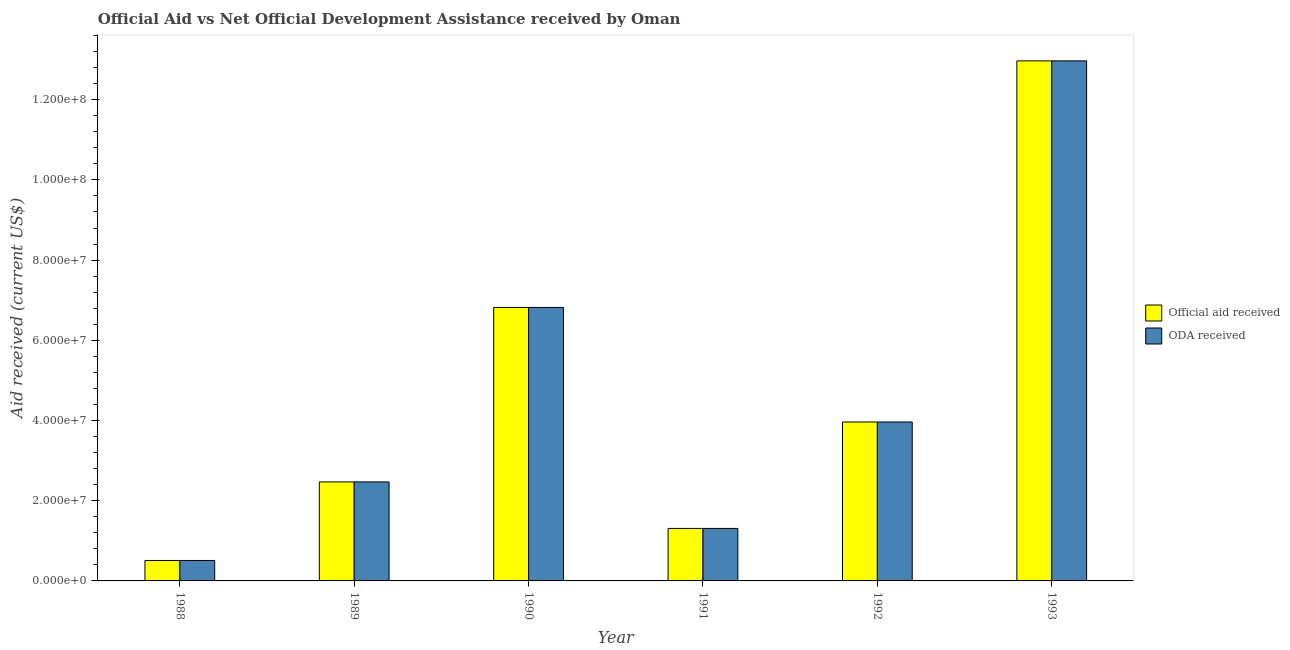How many groups of bars are there?
Your answer should be very brief. 6. Are the number of bars per tick equal to the number of legend labels?
Give a very brief answer. Yes. How many bars are there on the 3rd tick from the right?
Keep it short and to the point. 2. What is the label of the 6th group of bars from the left?
Give a very brief answer. 1993. What is the oda received in 1992?
Offer a terse response. 3.96e+07. Across all years, what is the maximum official aid received?
Offer a very short reply. 1.30e+08. Across all years, what is the minimum official aid received?
Make the answer very short. 5.10e+06. In which year was the official aid received minimum?
Provide a succinct answer. 1988. What is the total oda received in the graph?
Keep it short and to the point. 2.80e+08. What is the difference between the oda received in 1988 and that in 1989?
Your response must be concise. -1.96e+07. What is the difference between the official aid received in 1991 and the oda received in 1989?
Make the answer very short. -1.16e+07. What is the average oda received per year?
Keep it short and to the point. 4.67e+07. In the year 1990, what is the difference between the oda received and official aid received?
Provide a succinct answer. 0. What is the ratio of the oda received in 1988 to that in 1990?
Ensure brevity in your answer.  0.07. Is the oda received in 1989 less than that in 1993?
Provide a succinct answer. Yes. Is the difference between the official aid received in 1991 and 1992 greater than the difference between the oda received in 1991 and 1992?
Provide a short and direct response. No. What is the difference between the highest and the second highest oda received?
Your answer should be very brief. 6.15e+07. What is the difference between the highest and the lowest official aid received?
Offer a terse response. 1.25e+08. What does the 2nd bar from the left in 1988 represents?
Your answer should be very brief. ODA received. What does the 2nd bar from the right in 1993 represents?
Offer a very short reply. Official aid received. What is the difference between two consecutive major ticks on the Y-axis?
Your answer should be very brief. 2.00e+07. Are the values on the major ticks of Y-axis written in scientific E-notation?
Your answer should be very brief. Yes. Does the graph contain any zero values?
Your response must be concise. No. What is the title of the graph?
Offer a very short reply. Official Aid vs Net Official Development Assistance received by Oman . What is the label or title of the X-axis?
Make the answer very short. Year. What is the label or title of the Y-axis?
Ensure brevity in your answer.  Aid received (current US$). What is the Aid received (current US$) of Official aid received in 1988?
Offer a very short reply. 5.10e+06. What is the Aid received (current US$) of ODA received in 1988?
Keep it short and to the point. 5.10e+06. What is the Aid received (current US$) in Official aid received in 1989?
Offer a terse response. 2.47e+07. What is the Aid received (current US$) of ODA received in 1989?
Your answer should be compact. 2.47e+07. What is the Aid received (current US$) of Official aid received in 1990?
Make the answer very short. 6.82e+07. What is the Aid received (current US$) of ODA received in 1990?
Keep it short and to the point. 6.82e+07. What is the Aid received (current US$) of Official aid received in 1991?
Provide a succinct answer. 1.31e+07. What is the Aid received (current US$) of ODA received in 1991?
Provide a succinct answer. 1.31e+07. What is the Aid received (current US$) of Official aid received in 1992?
Your answer should be compact. 3.96e+07. What is the Aid received (current US$) of ODA received in 1992?
Your answer should be compact. 3.96e+07. What is the Aid received (current US$) in Official aid received in 1993?
Make the answer very short. 1.30e+08. What is the Aid received (current US$) of ODA received in 1993?
Your answer should be very brief. 1.30e+08. Across all years, what is the maximum Aid received (current US$) in Official aid received?
Provide a short and direct response. 1.30e+08. Across all years, what is the maximum Aid received (current US$) of ODA received?
Your answer should be compact. 1.30e+08. Across all years, what is the minimum Aid received (current US$) in Official aid received?
Give a very brief answer. 5.10e+06. Across all years, what is the minimum Aid received (current US$) of ODA received?
Your answer should be compact. 5.10e+06. What is the total Aid received (current US$) in Official aid received in the graph?
Keep it short and to the point. 2.80e+08. What is the total Aid received (current US$) in ODA received in the graph?
Offer a very short reply. 2.80e+08. What is the difference between the Aid received (current US$) in Official aid received in 1988 and that in 1989?
Offer a terse response. -1.96e+07. What is the difference between the Aid received (current US$) in ODA received in 1988 and that in 1989?
Offer a terse response. -1.96e+07. What is the difference between the Aid received (current US$) of Official aid received in 1988 and that in 1990?
Provide a short and direct response. -6.31e+07. What is the difference between the Aid received (current US$) of ODA received in 1988 and that in 1990?
Your response must be concise. -6.31e+07. What is the difference between the Aid received (current US$) in Official aid received in 1988 and that in 1991?
Keep it short and to the point. -7.99e+06. What is the difference between the Aid received (current US$) of ODA received in 1988 and that in 1991?
Offer a very short reply. -7.99e+06. What is the difference between the Aid received (current US$) of Official aid received in 1988 and that in 1992?
Make the answer very short. -3.45e+07. What is the difference between the Aid received (current US$) in ODA received in 1988 and that in 1992?
Give a very brief answer. -3.45e+07. What is the difference between the Aid received (current US$) of Official aid received in 1988 and that in 1993?
Keep it short and to the point. -1.25e+08. What is the difference between the Aid received (current US$) in ODA received in 1988 and that in 1993?
Offer a terse response. -1.25e+08. What is the difference between the Aid received (current US$) of Official aid received in 1989 and that in 1990?
Ensure brevity in your answer.  -4.35e+07. What is the difference between the Aid received (current US$) in ODA received in 1989 and that in 1990?
Your response must be concise. -4.35e+07. What is the difference between the Aid received (current US$) in Official aid received in 1989 and that in 1991?
Your answer should be very brief. 1.16e+07. What is the difference between the Aid received (current US$) in ODA received in 1989 and that in 1991?
Ensure brevity in your answer.  1.16e+07. What is the difference between the Aid received (current US$) in Official aid received in 1989 and that in 1992?
Your answer should be compact. -1.49e+07. What is the difference between the Aid received (current US$) of ODA received in 1989 and that in 1992?
Offer a very short reply. -1.49e+07. What is the difference between the Aid received (current US$) of Official aid received in 1989 and that in 1993?
Keep it short and to the point. -1.05e+08. What is the difference between the Aid received (current US$) in ODA received in 1989 and that in 1993?
Give a very brief answer. -1.05e+08. What is the difference between the Aid received (current US$) of Official aid received in 1990 and that in 1991?
Your answer should be very brief. 5.51e+07. What is the difference between the Aid received (current US$) of ODA received in 1990 and that in 1991?
Your answer should be compact. 5.51e+07. What is the difference between the Aid received (current US$) of Official aid received in 1990 and that in 1992?
Give a very brief answer. 2.86e+07. What is the difference between the Aid received (current US$) in ODA received in 1990 and that in 1992?
Keep it short and to the point. 2.86e+07. What is the difference between the Aid received (current US$) of Official aid received in 1990 and that in 1993?
Offer a very short reply. -6.15e+07. What is the difference between the Aid received (current US$) in ODA received in 1990 and that in 1993?
Provide a short and direct response. -6.15e+07. What is the difference between the Aid received (current US$) in Official aid received in 1991 and that in 1992?
Your answer should be compact. -2.65e+07. What is the difference between the Aid received (current US$) in ODA received in 1991 and that in 1992?
Make the answer very short. -2.65e+07. What is the difference between the Aid received (current US$) in Official aid received in 1991 and that in 1993?
Make the answer very short. -1.17e+08. What is the difference between the Aid received (current US$) of ODA received in 1991 and that in 1993?
Offer a very short reply. -1.17e+08. What is the difference between the Aid received (current US$) of Official aid received in 1992 and that in 1993?
Keep it short and to the point. -9.00e+07. What is the difference between the Aid received (current US$) in ODA received in 1992 and that in 1993?
Ensure brevity in your answer.  -9.00e+07. What is the difference between the Aid received (current US$) in Official aid received in 1988 and the Aid received (current US$) in ODA received in 1989?
Your response must be concise. -1.96e+07. What is the difference between the Aid received (current US$) of Official aid received in 1988 and the Aid received (current US$) of ODA received in 1990?
Offer a very short reply. -6.31e+07. What is the difference between the Aid received (current US$) in Official aid received in 1988 and the Aid received (current US$) in ODA received in 1991?
Your response must be concise. -7.99e+06. What is the difference between the Aid received (current US$) of Official aid received in 1988 and the Aid received (current US$) of ODA received in 1992?
Offer a terse response. -3.45e+07. What is the difference between the Aid received (current US$) of Official aid received in 1988 and the Aid received (current US$) of ODA received in 1993?
Make the answer very short. -1.25e+08. What is the difference between the Aid received (current US$) of Official aid received in 1989 and the Aid received (current US$) of ODA received in 1990?
Offer a terse response. -4.35e+07. What is the difference between the Aid received (current US$) in Official aid received in 1989 and the Aid received (current US$) in ODA received in 1991?
Ensure brevity in your answer.  1.16e+07. What is the difference between the Aid received (current US$) of Official aid received in 1989 and the Aid received (current US$) of ODA received in 1992?
Your response must be concise. -1.49e+07. What is the difference between the Aid received (current US$) in Official aid received in 1989 and the Aid received (current US$) in ODA received in 1993?
Offer a terse response. -1.05e+08. What is the difference between the Aid received (current US$) in Official aid received in 1990 and the Aid received (current US$) in ODA received in 1991?
Keep it short and to the point. 5.51e+07. What is the difference between the Aid received (current US$) in Official aid received in 1990 and the Aid received (current US$) in ODA received in 1992?
Ensure brevity in your answer.  2.86e+07. What is the difference between the Aid received (current US$) of Official aid received in 1990 and the Aid received (current US$) of ODA received in 1993?
Keep it short and to the point. -6.15e+07. What is the difference between the Aid received (current US$) in Official aid received in 1991 and the Aid received (current US$) in ODA received in 1992?
Provide a short and direct response. -2.65e+07. What is the difference between the Aid received (current US$) in Official aid received in 1991 and the Aid received (current US$) in ODA received in 1993?
Provide a short and direct response. -1.17e+08. What is the difference between the Aid received (current US$) of Official aid received in 1992 and the Aid received (current US$) of ODA received in 1993?
Make the answer very short. -9.00e+07. What is the average Aid received (current US$) of Official aid received per year?
Make the answer very short. 4.67e+07. What is the average Aid received (current US$) in ODA received per year?
Your answer should be compact. 4.67e+07. In the year 1988, what is the difference between the Aid received (current US$) in Official aid received and Aid received (current US$) in ODA received?
Provide a succinct answer. 0. In the year 1991, what is the difference between the Aid received (current US$) in Official aid received and Aid received (current US$) in ODA received?
Your response must be concise. 0. In the year 1992, what is the difference between the Aid received (current US$) in Official aid received and Aid received (current US$) in ODA received?
Your answer should be very brief. 0. In the year 1993, what is the difference between the Aid received (current US$) in Official aid received and Aid received (current US$) in ODA received?
Your answer should be very brief. 0. What is the ratio of the Aid received (current US$) of Official aid received in 1988 to that in 1989?
Your answer should be compact. 0.21. What is the ratio of the Aid received (current US$) of ODA received in 1988 to that in 1989?
Provide a succinct answer. 0.21. What is the ratio of the Aid received (current US$) of Official aid received in 1988 to that in 1990?
Make the answer very short. 0.07. What is the ratio of the Aid received (current US$) in ODA received in 1988 to that in 1990?
Provide a short and direct response. 0.07. What is the ratio of the Aid received (current US$) of Official aid received in 1988 to that in 1991?
Your response must be concise. 0.39. What is the ratio of the Aid received (current US$) in ODA received in 1988 to that in 1991?
Your response must be concise. 0.39. What is the ratio of the Aid received (current US$) in Official aid received in 1988 to that in 1992?
Offer a terse response. 0.13. What is the ratio of the Aid received (current US$) in ODA received in 1988 to that in 1992?
Give a very brief answer. 0.13. What is the ratio of the Aid received (current US$) of Official aid received in 1988 to that in 1993?
Make the answer very short. 0.04. What is the ratio of the Aid received (current US$) of ODA received in 1988 to that in 1993?
Your answer should be compact. 0.04. What is the ratio of the Aid received (current US$) of Official aid received in 1989 to that in 1990?
Provide a short and direct response. 0.36. What is the ratio of the Aid received (current US$) in ODA received in 1989 to that in 1990?
Your response must be concise. 0.36. What is the ratio of the Aid received (current US$) in Official aid received in 1989 to that in 1991?
Ensure brevity in your answer.  1.89. What is the ratio of the Aid received (current US$) of ODA received in 1989 to that in 1991?
Provide a short and direct response. 1.89. What is the ratio of the Aid received (current US$) of Official aid received in 1989 to that in 1992?
Your answer should be very brief. 0.62. What is the ratio of the Aid received (current US$) in ODA received in 1989 to that in 1992?
Offer a terse response. 0.62. What is the ratio of the Aid received (current US$) of Official aid received in 1989 to that in 1993?
Ensure brevity in your answer.  0.19. What is the ratio of the Aid received (current US$) of ODA received in 1989 to that in 1993?
Your answer should be compact. 0.19. What is the ratio of the Aid received (current US$) of Official aid received in 1990 to that in 1991?
Your answer should be very brief. 5.21. What is the ratio of the Aid received (current US$) of ODA received in 1990 to that in 1991?
Ensure brevity in your answer.  5.21. What is the ratio of the Aid received (current US$) of Official aid received in 1990 to that in 1992?
Keep it short and to the point. 1.72. What is the ratio of the Aid received (current US$) in ODA received in 1990 to that in 1992?
Offer a terse response. 1.72. What is the ratio of the Aid received (current US$) of Official aid received in 1990 to that in 1993?
Ensure brevity in your answer.  0.53. What is the ratio of the Aid received (current US$) in ODA received in 1990 to that in 1993?
Give a very brief answer. 0.53. What is the ratio of the Aid received (current US$) of Official aid received in 1991 to that in 1992?
Offer a terse response. 0.33. What is the ratio of the Aid received (current US$) in ODA received in 1991 to that in 1992?
Provide a succinct answer. 0.33. What is the ratio of the Aid received (current US$) in Official aid received in 1991 to that in 1993?
Provide a short and direct response. 0.1. What is the ratio of the Aid received (current US$) of ODA received in 1991 to that in 1993?
Your answer should be compact. 0.1. What is the ratio of the Aid received (current US$) in Official aid received in 1992 to that in 1993?
Provide a succinct answer. 0.31. What is the ratio of the Aid received (current US$) in ODA received in 1992 to that in 1993?
Make the answer very short. 0.31. What is the difference between the highest and the second highest Aid received (current US$) of Official aid received?
Keep it short and to the point. 6.15e+07. What is the difference between the highest and the second highest Aid received (current US$) of ODA received?
Your answer should be compact. 6.15e+07. What is the difference between the highest and the lowest Aid received (current US$) in Official aid received?
Offer a very short reply. 1.25e+08. What is the difference between the highest and the lowest Aid received (current US$) of ODA received?
Your response must be concise. 1.25e+08. 